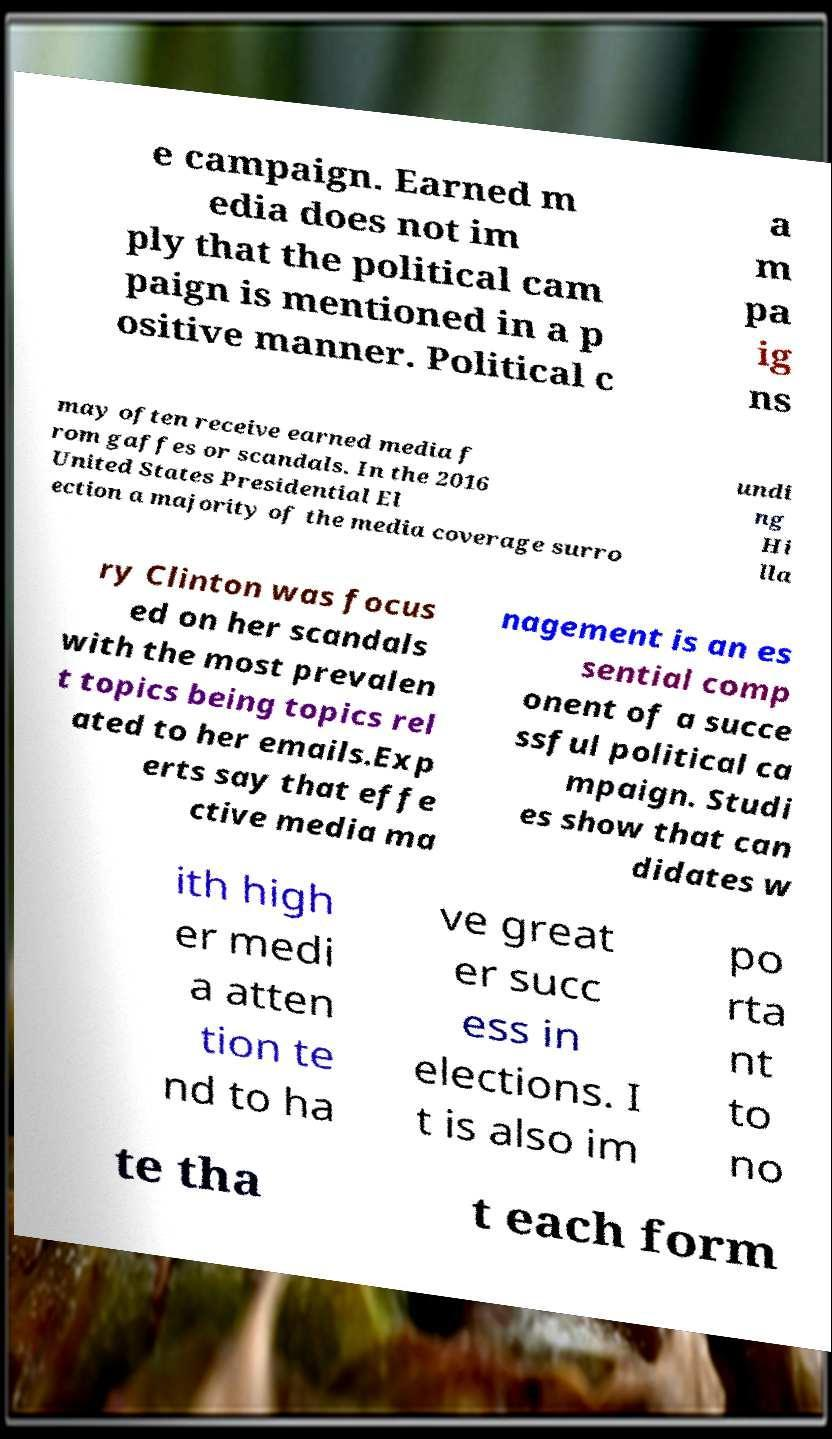I need the written content from this picture converted into text. Can you do that? e campaign. Earned m edia does not im ply that the political cam paign is mentioned in a p ositive manner. Political c a m pa ig ns may often receive earned media f rom gaffes or scandals. In the 2016 United States Presidential El ection a majority of the media coverage surro undi ng Hi lla ry Clinton was focus ed on her scandals with the most prevalen t topics being topics rel ated to her emails.Exp erts say that effe ctive media ma nagement is an es sential comp onent of a succe ssful political ca mpaign. Studi es show that can didates w ith high er medi a atten tion te nd to ha ve great er succ ess in elections. I t is also im po rta nt to no te tha t each form 